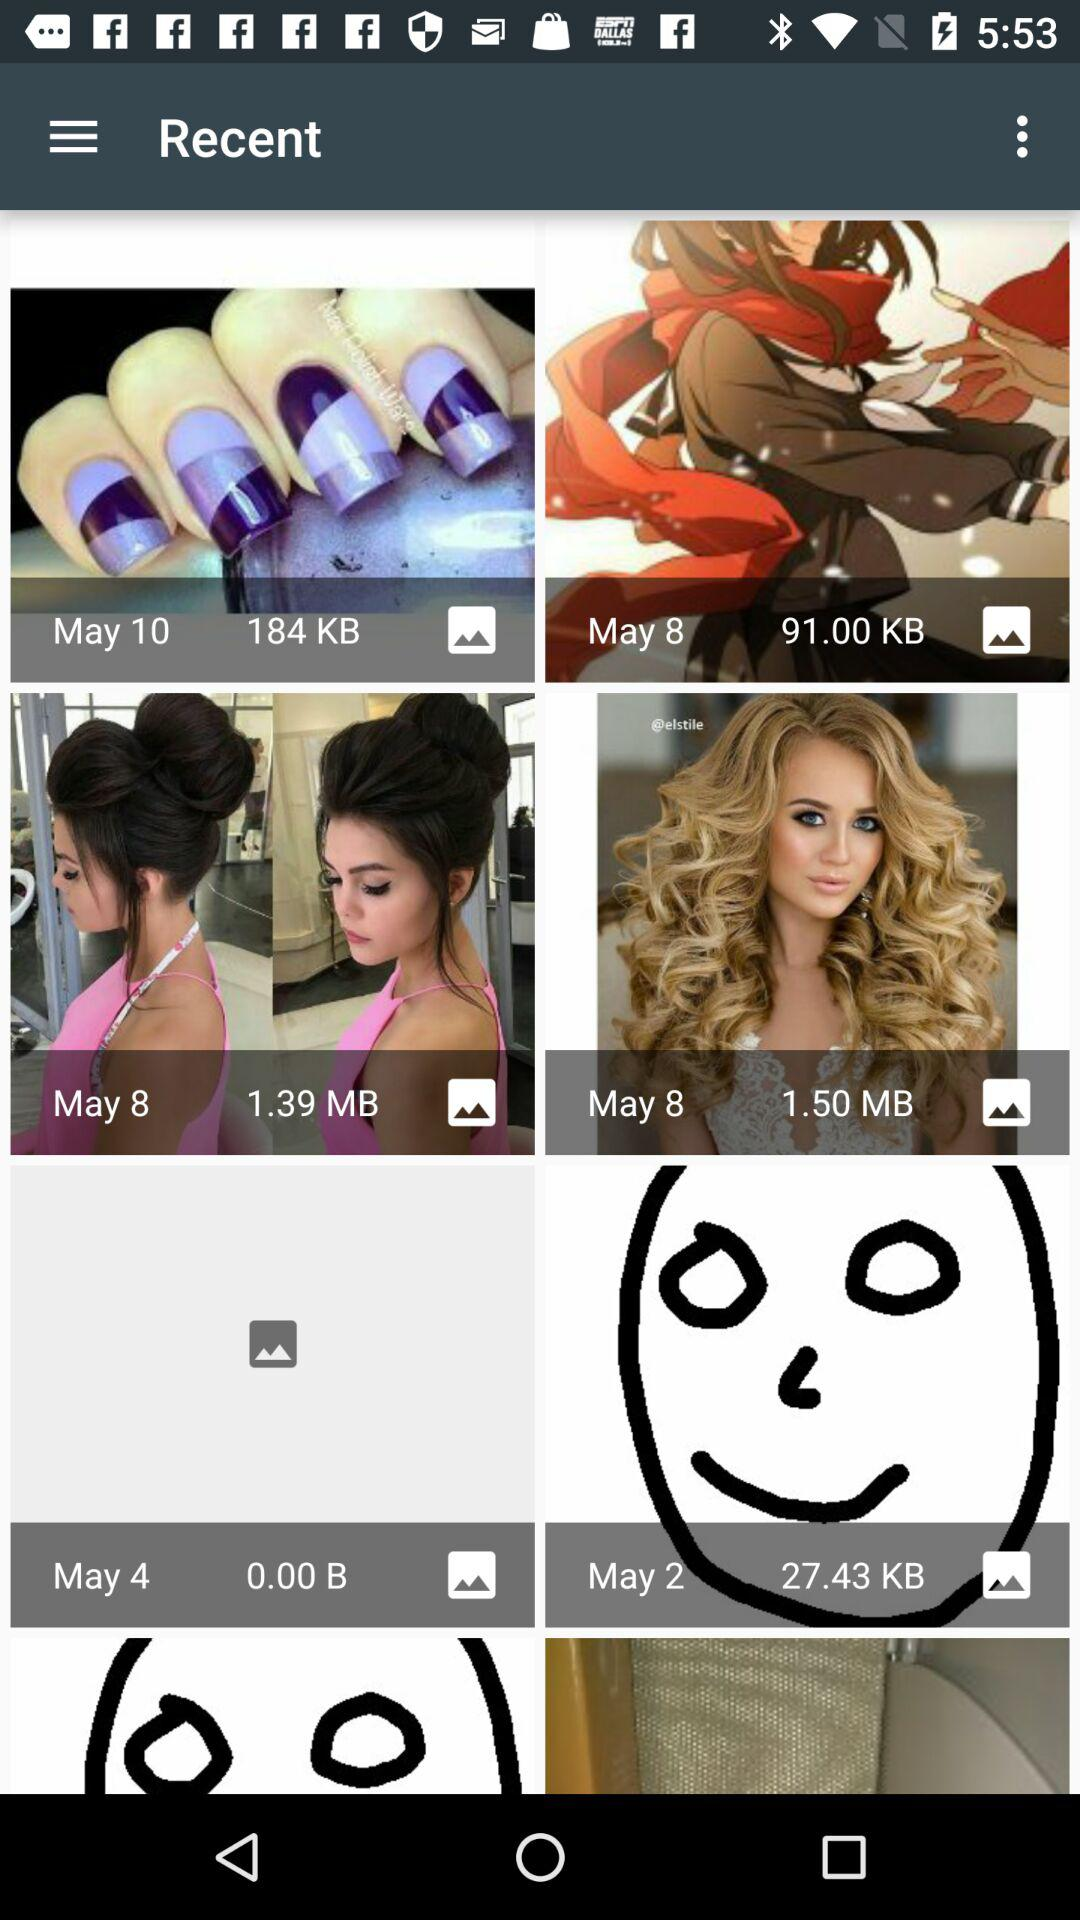What is the size of the image clicked on May 10? The size of the image is 184 KB. 